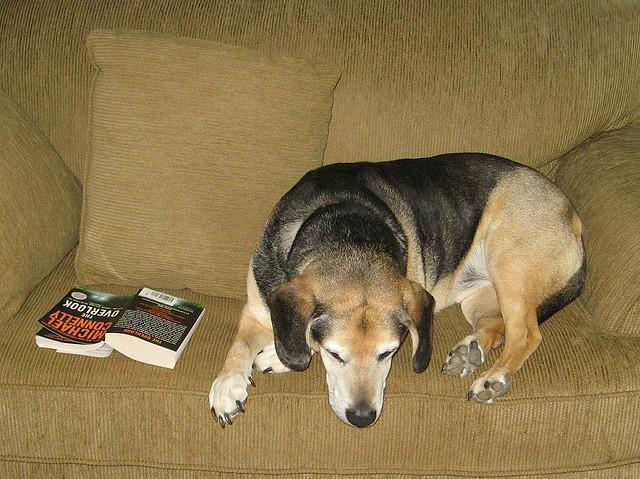How many dogs can be seen?
Give a very brief answer. 1. How many trains are on the track?
Give a very brief answer. 0. 